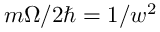<formula> <loc_0><loc_0><loc_500><loc_500>m \Omega / 2 \hbar { = } 1 / w ^ { 2 }</formula> 